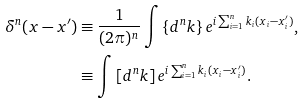<formula> <loc_0><loc_0><loc_500><loc_500>\delta ^ { n } ( x - x ^ { \prime } ) & \equiv \frac { 1 } { ( 2 \pi ) ^ { n } } \int \left \{ d ^ { n } k \right \} e ^ { i \sum _ { i = 1 } ^ { n } k _ { i } ( x _ { i } - x ^ { \prime } _ { i } ) } , \\ & \equiv \int \left [ d ^ { n } k \right ] e ^ { i \sum _ { i = 1 } ^ { n } k _ { i } ( x _ { i } - x _ { i } ^ { \prime } ) } .</formula> 